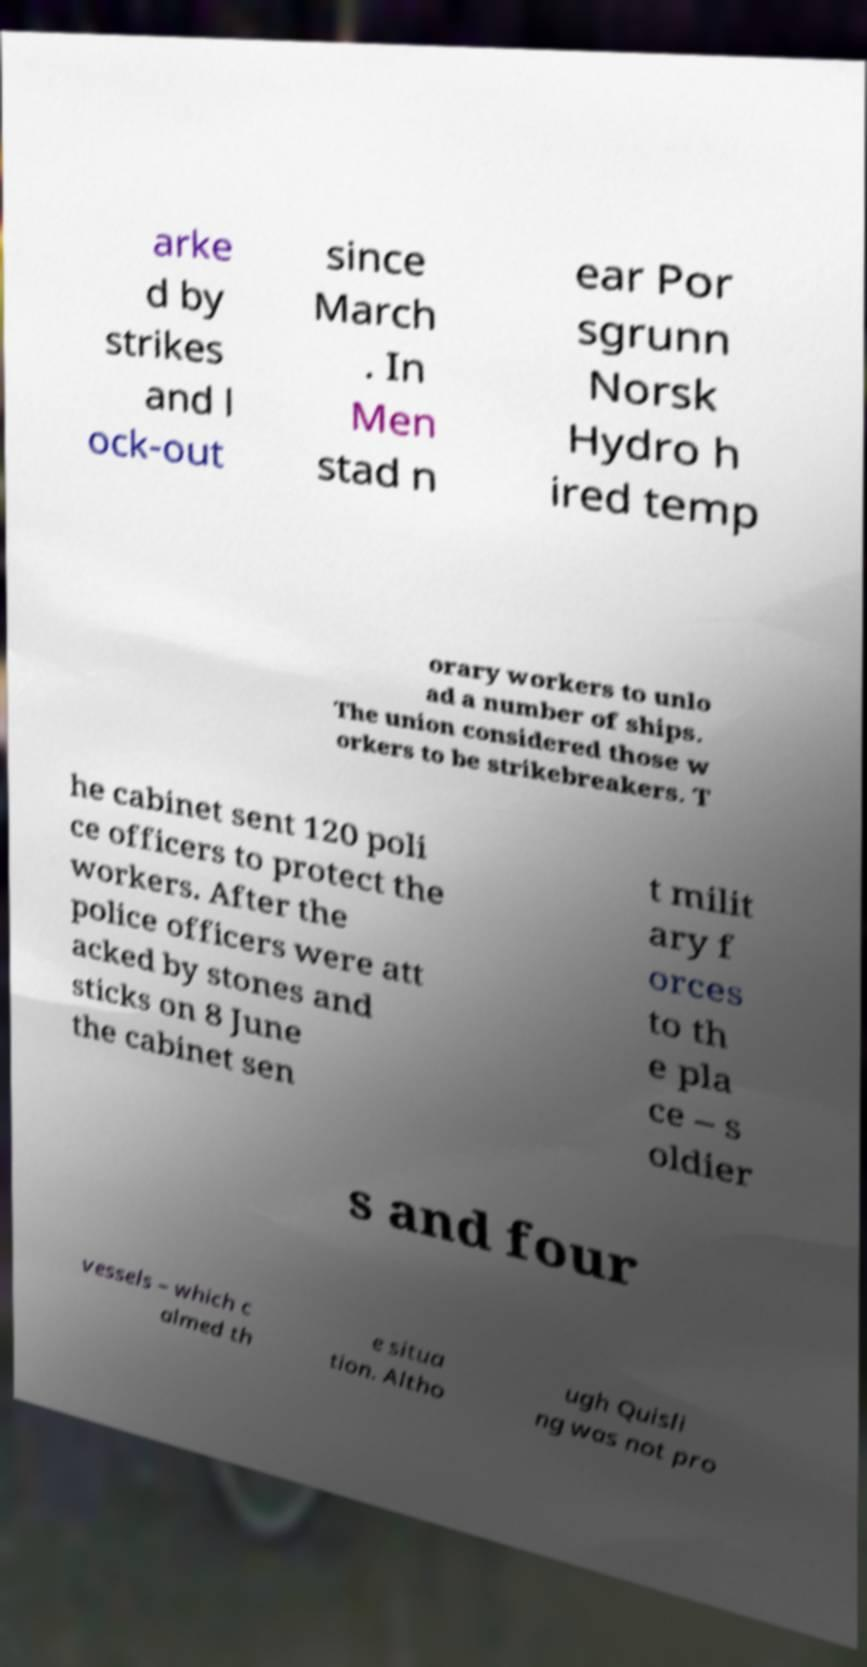Can you read and provide the text displayed in the image?This photo seems to have some interesting text. Can you extract and type it out for me? arke d by strikes and l ock-out since March . In Men stad n ear Por sgrunn Norsk Hydro h ired temp orary workers to unlo ad a number of ships. The union considered those w orkers to be strikebreakers. T he cabinet sent 120 poli ce officers to protect the workers. After the police officers were att acked by stones and sticks on 8 June the cabinet sen t milit ary f orces to th e pla ce – s oldier s and four vessels – which c almed th e situa tion. Altho ugh Quisli ng was not pro 